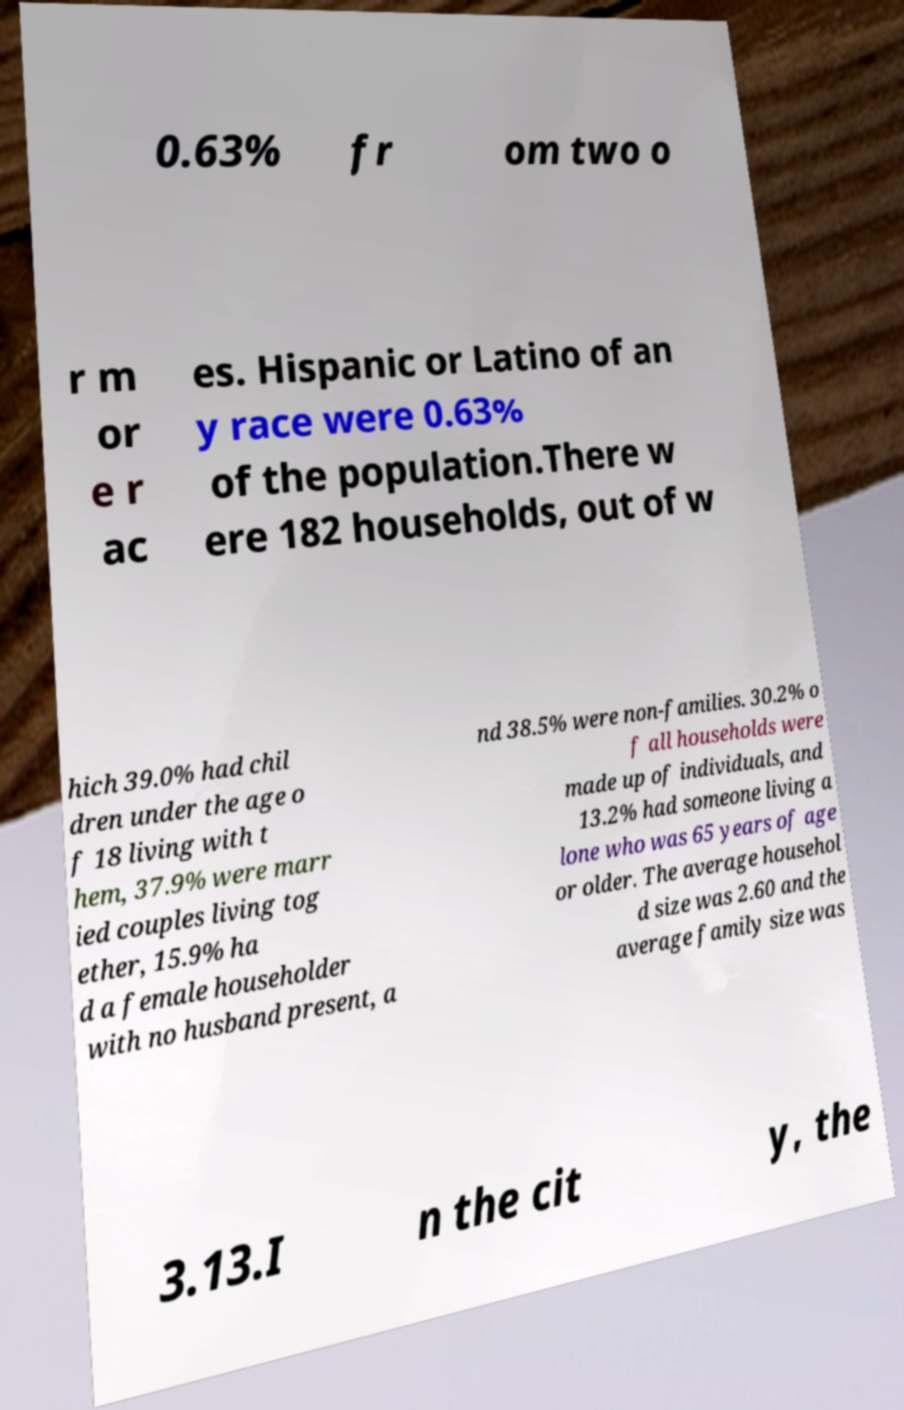Could you assist in decoding the text presented in this image and type it out clearly? 0.63% fr om two o r m or e r ac es. Hispanic or Latino of an y race were 0.63% of the population.There w ere 182 households, out of w hich 39.0% had chil dren under the age o f 18 living with t hem, 37.9% were marr ied couples living tog ether, 15.9% ha d a female householder with no husband present, a nd 38.5% were non-families. 30.2% o f all households were made up of individuals, and 13.2% had someone living a lone who was 65 years of age or older. The average househol d size was 2.60 and the average family size was 3.13.I n the cit y, the 